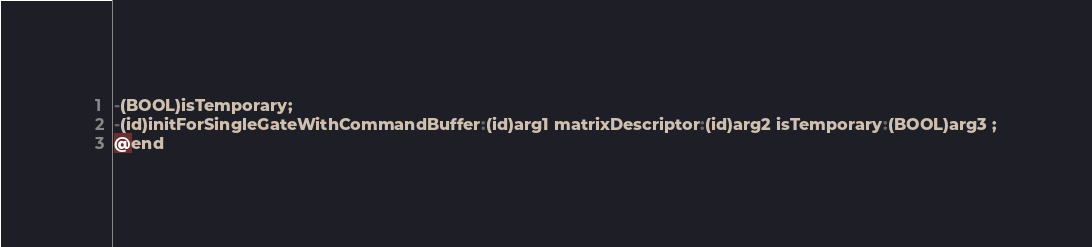Convert code to text. <code><loc_0><loc_0><loc_500><loc_500><_C_>-(BOOL)isTemporary;
-(id)initForSingleGateWithCommandBuffer:(id)arg1 matrixDescriptor:(id)arg2 isTemporary:(BOOL)arg3 ;
@end

</code> 